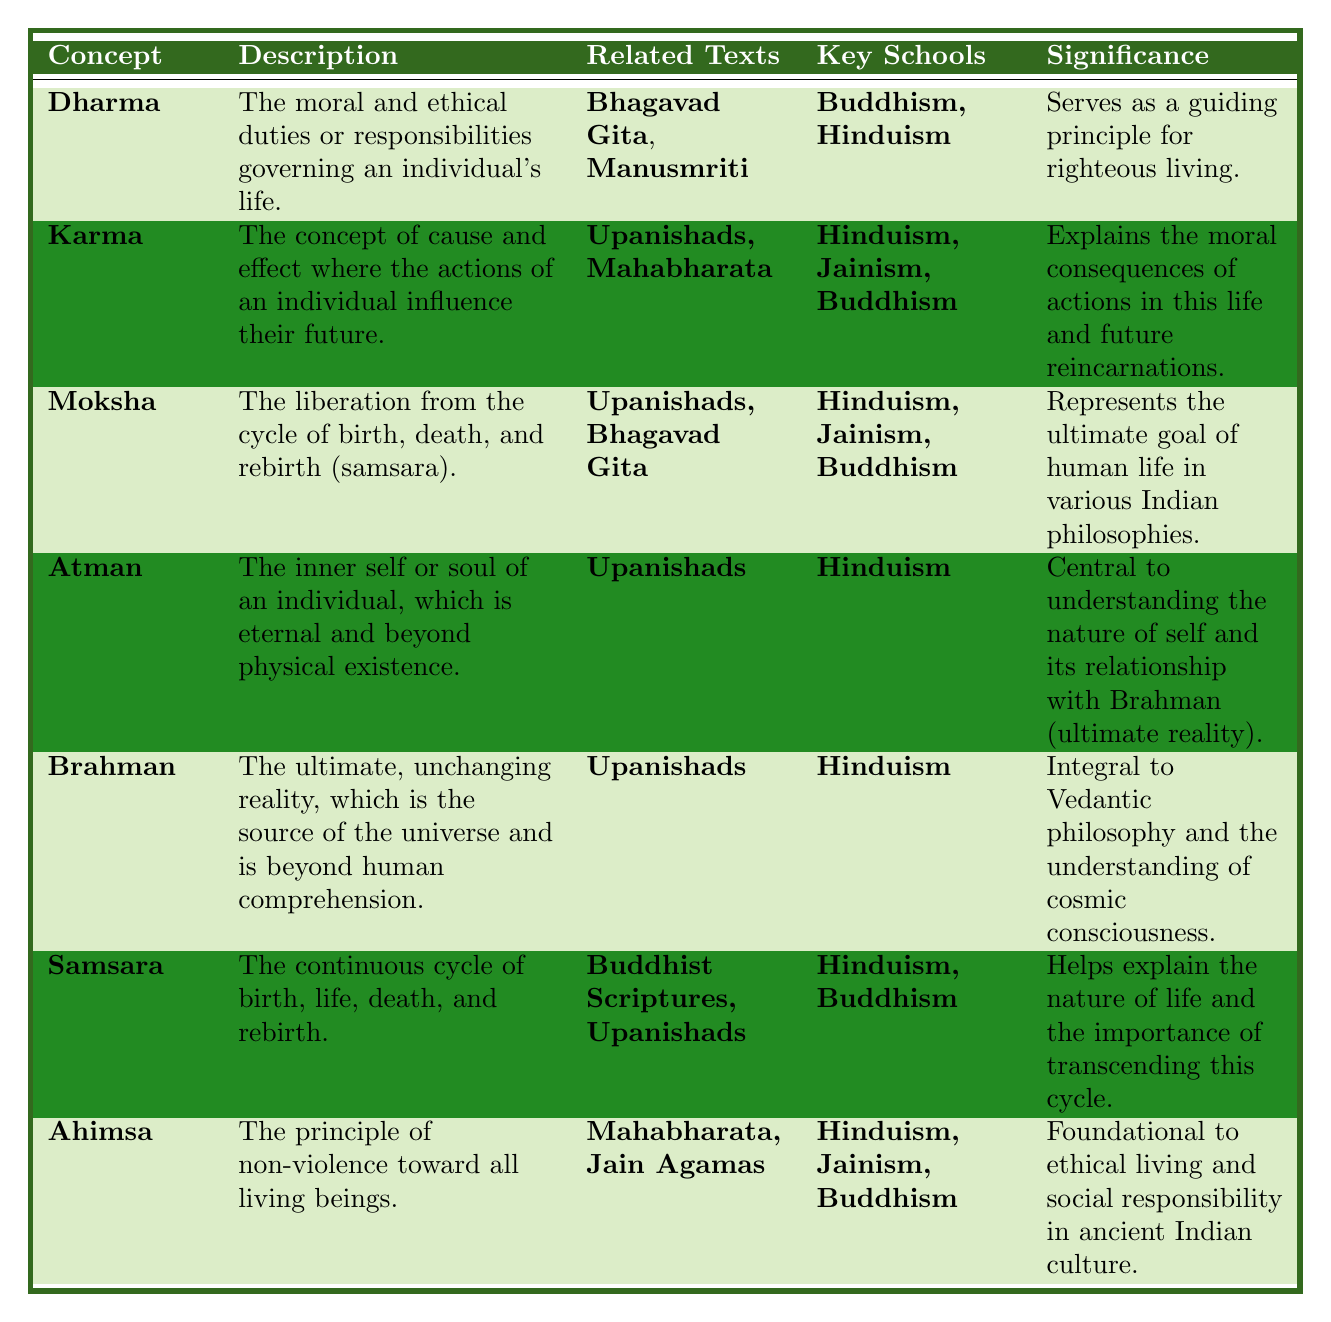What is the significance of **Karma** in ancient Indian philosophy? According to the table, **Karma** explains the moral consequences of actions in this life and future reincarnations, which highlights its importance in ethical decision-making.
Answer: Explains moral consequences of actions Which philosophical concept is associated with the **Bhagavad Gita**? The table indicates that both **Dharma** and **Moksha** are related to **Bhagavad Gita**, making them significant philosophical concepts associated with this text.
Answer: **Dharma** and **Moksha** Is **Ahimsa** related to **Buddhism**? The table clearly shows that **Ahimsa** is significant in **Hinduism**, **Jainism**, and **Buddhism**, confirming its connection to Buddhism.
Answer: Yes How many key schools are associated with **Moksha**? The table states that **Moksha** is associated with three key schools: **Hinduism**, **Jainism**, and **Buddhism**. Therefore, the total count is three.
Answer: Three Which concepts relate to the principle of **non-violence**? The table indicates that **Ahimsa** relates to non-violence and is associated with **Hinduism**, **Jainism**, and **Buddhism**. Therefore, the relevant concept is **Ahimsa** itself.
Answer: **Ahimsa** What is the commonality between **Brahman** and **Atman**? Both concepts are central to **Hinduism** and have their roots in the **Upanishads**, where **Atman** refers to the inner self, and **Brahman** represents ultimate reality.
Answer: Both are central to **Hinduism** How does the significance of **Dharma** compare to **Moksha** regarding life's goals? **Dharma** serves as a guiding principle for righteous living, while **Moksha** is identified as the ultimate goal of human life, indicating that **Moksha** is a higher life goal in contrast to the day-to-day guidance that **Dharma** provides.
Answer: **Moksha** is the ultimate goal, while **Dharma** guides daily actions Which philosophical concepts are described as part of the **cycle of samsara**? The table identifies **Samsara** as the continuous cycle of birth, life, death, and rebirth, and it highlights **Moksha** as liberation from this cycle, making both concepts integral to understanding samsara.
Answer: **Samsara** and **Moksha** What texts are associated with **Karma** and **Samsara**? The table lists **Karma** related to the **Upanishads** and **Mahabharata**, while **Samsara** is associated with **Buddhist Scriptures** and **Upanishads**. This shows the overlap of texts, especially the **Upanishads**.
Answer: **Upanishads**, **Mahabharata** for **Karma**; **Buddhist Scriptures**, **Upanishads** for **Samsara** 